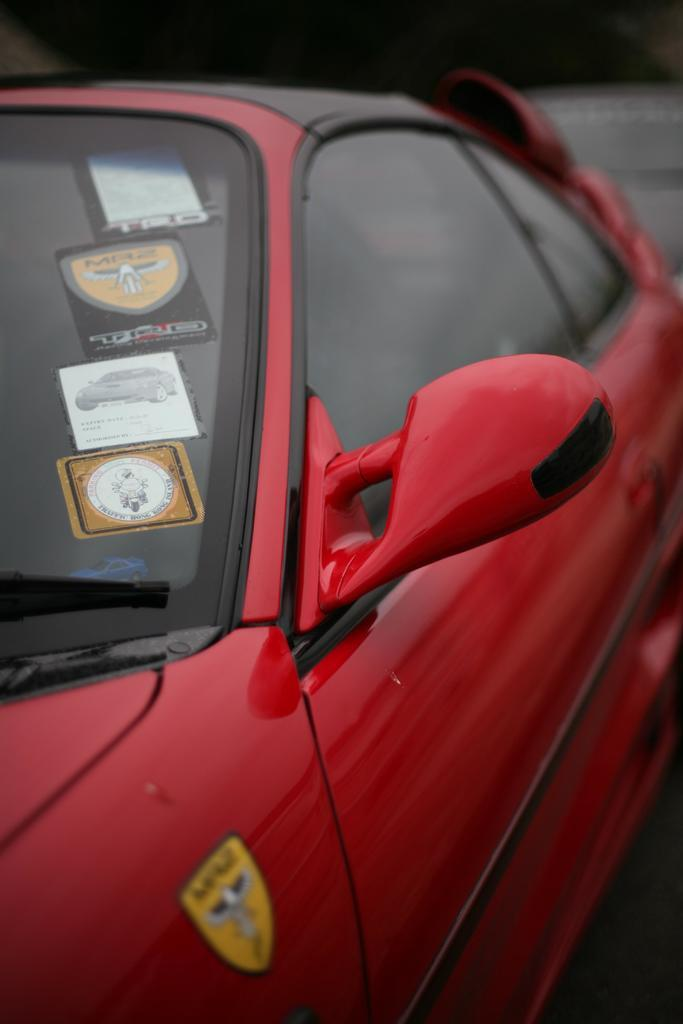What is the main subject of the image? There is a car in the image. Where is the car located in the image? The car is in the center of the image. What color is the car? The car is red in color. How many firemen are holding hands around the car in the image? There are no firemen or hands visible in the image; it only features a red car in the center. 